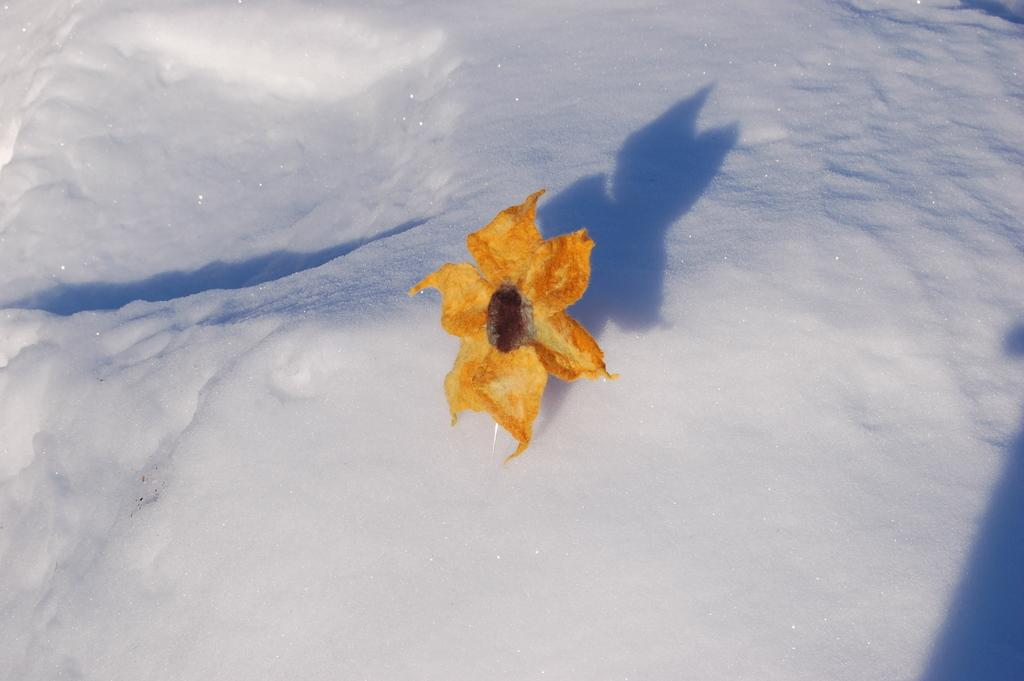What is the main subject of the image? The main subject of the image is a flower. Where is the flower located? The flower is on the snow. What type of soda is being poured on the flower in the image? There is no soda present in the image; it only features a flower on the snow. What color are the trousers of the person holding the flower in the image? There is no person holding the flower in the image, as it only features a flower on the snow. 